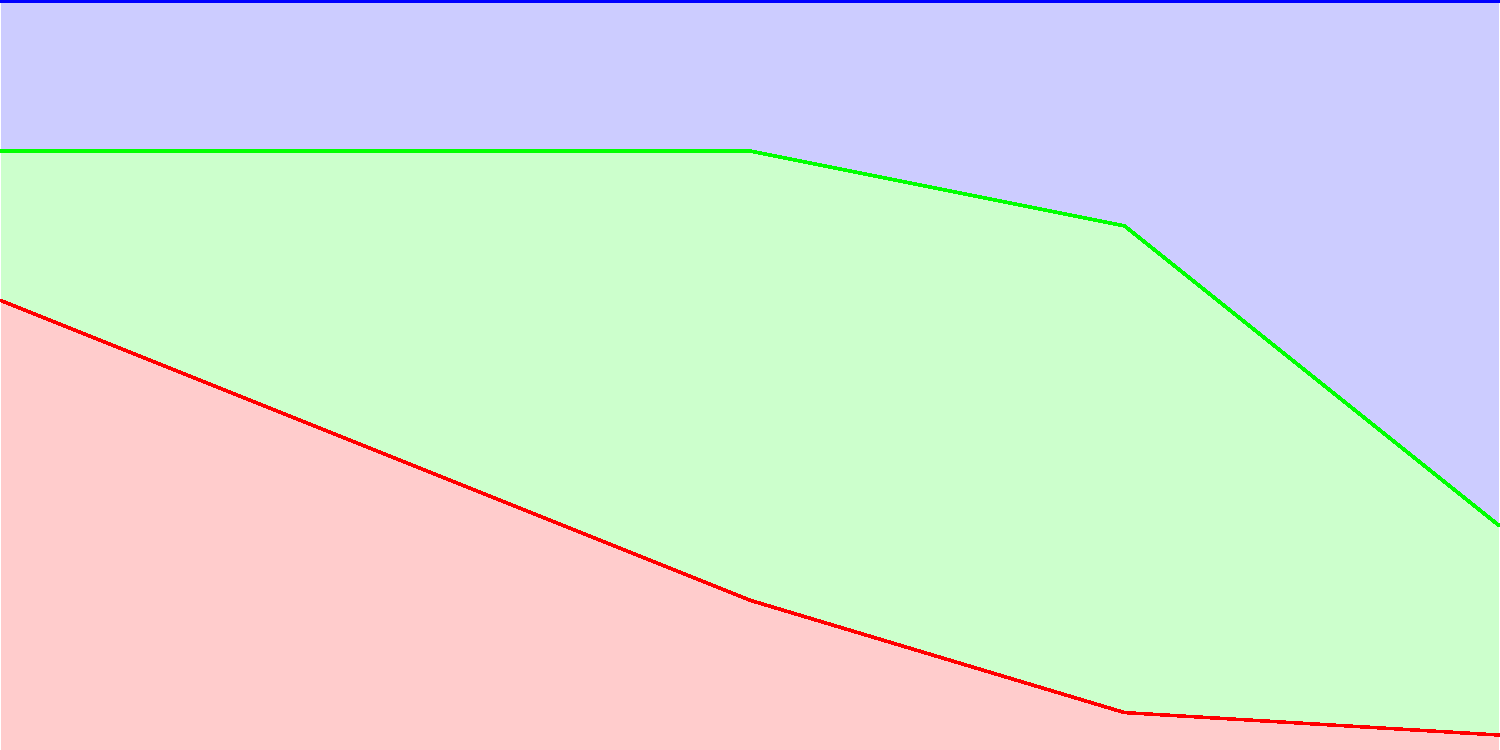Analyze the stacked vector arrow diagram depicting the changing composition of the British working class from 1800 to 2000. Which sector experienced the most significant growth, and approximately when did it surpass the other sectors in terms of workforce percentage? To answer this question, we need to examine the trends in each sector over time:

1. Agricultural sector (red):
   - Starts at about 60% in 1800
   - Steadily declines throughout the period
   - Reaches approximately 2% by 2000

2. Industrial sector (green):
   - Starts at about 20% in 1800
   - Rises to peak at around 65% in 1950
   - Declines to about 28% by 2000

3. Service sector (blue):
   - Starts at about 20% in 1800
   - Remains relatively stable until 1900
   - Begins to rise rapidly after 1950
   - Reaches approximately 70% by 2000

The service sector experienced the most significant growth, especially in the latter half of the 20th century. It surpassed the other sectors around 1975-1980, as we can see the blue area overtaking the green (industrial) and red (agricultural) areas on the graph during this period.

This shift reflects the transition from an industrial economy to a post-industrial, service-based economy in Britain, a trend observed in many developed countries during the late 20th century.
Answer: Service sector, circa 1975-1980 